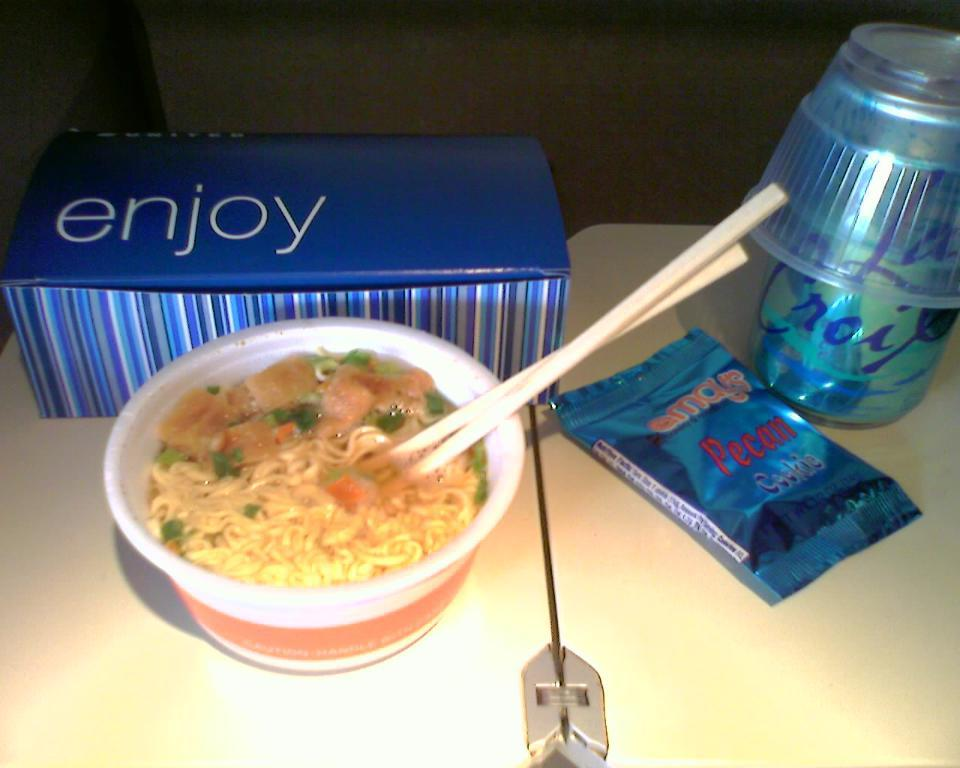<image>
Provide a brief description of the given image. A can of La Croix next to a bowl of soup and a box with enjoy on it. 